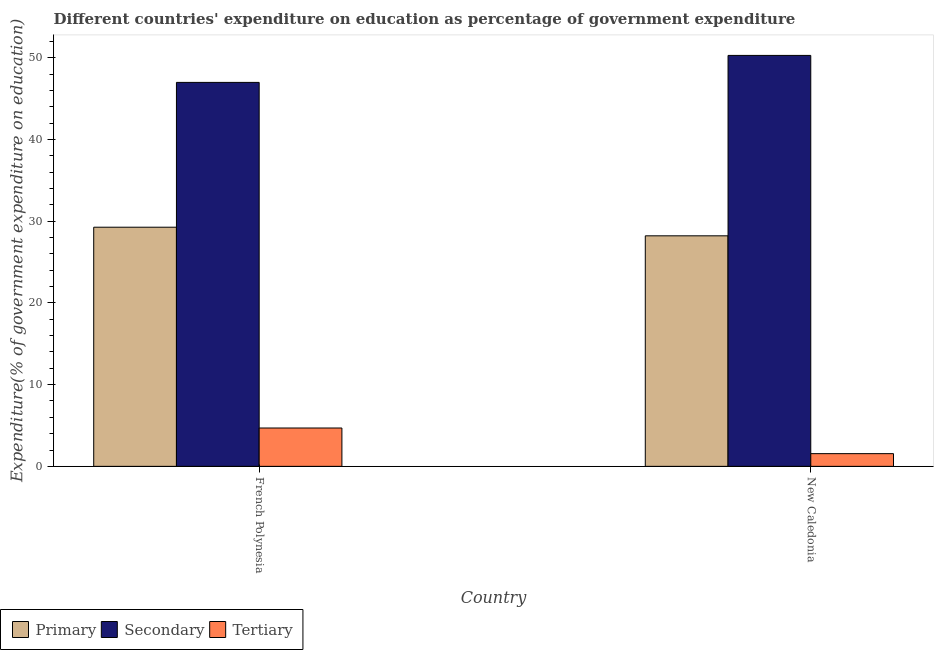How many different coloured bars are there?
Your response must be concise. 3. How many groups of bars are there?
Provide a short and direct response. 2. Are the number of bars on each tick of the X-axis equal?
Ensure brevity in your answer.  Yes. What is the label of the 2nd group of bars from the left?
Offer a very short reply. New Caledonia. In how many cases, is the number of bars for a given country not equal to the number of legend labels?
Make the answer very short. 0. What is the expenditure on tertiary education in New Caledonia?
Make the answer very short. 1.55. Across all countries, what is the maximum expenditure on secondary education?
Make the answer very short. 50.29. Across all countries, what is the minimum expenditure on tertiary education?
Your response must be concise. 1.55. In which country was the expenditure on primary education maximum?
Your answer should be very brief. French Polynesia. In which country was the expenditure on secondary education minimum?
Keep it short and to the point. French Polynesia. What is the total expenditure on primary education in the graph?
Your answer should be compact. 57.47. What is the difference between the expenditure on secondary education in French Polynesia and that in New Caledonia?
Give a very brief answer. -3.3. What is the difference between the expenditure on primary education in French Polynesia and the expenditure on tertiary education in New Caledonia?
Your answer should be very brief. 27.71. What is the average expenditure on secondary education per country?
Offer a very short reply. 48.64. What is the difference between the expenditure on tertiary education and expenditure on secondary education in New Caledonia?
Offer a very short reply. -48.73. What is the ratio of the expenditure on secondary education in French Polynesia to that in New Caledonia?
Your answer should be compact. 0.93. Is the expenditure on secondary education in French Polynesia less than that in New Caledonia?
Ensure brevity in your answer.  Yes. In how many countries, is the expenditure on tertiary education greater than the average expenditure on tertiary education taken over all countries?
Your answer should be very brief. 1. What does the 2nd bar from the left in New Caledonia represents?
Your answer should be compact. Secondary. What does the 3rd bar from the right in French Polynesia represents?
Your answer should be very brief. Primary. Is it the case that in every country, the sum of the expenditure on primary education and expenditure on secondary education is greater than the expenditure on tertiary education?
Offer a terse response. Yes. Are all the bars in the graph horizontal?
Offer a very short reply. No. What is the difference between two consecutive major ticks on the Y-axis?
Make the answer very short. 10. Does the graph contain any zero values?
Give a very brief answer. No. Does the graph contain grids?
Offer a very short reply. No. What is the title of the graph?
Offer a terse response. Different countries' expenditure on education as percentage of government expenditure. Does "Social Protection" appear as one of the legend labels in the graph?
Provide a short and direct response. No. What is the label or title of the Y-axis?
Provide a succinct answer. Expenditure(% of government expenditure on education). What is the Expenditure(% of government expenditure on education) in Primary in French Polynesia?
Give a very brief answer. 29.26. What is the Expenditure(% of government expenditure on education) in Secondary in French Polynesia?
Offer a terse response. 46.98. What is the Expenditure(% of government expenditure on education) in Tertiary in French Polynesia?
Give a very brief answer. 4.69. What is the Expenditure(% of government expenditure on education) in Primary in New Caledonia?
Make the answer very short. 28.21. What is the Expenditure(% of government expenditure on education) in Secondary in New Caledonia?
Offer a terse response. 50.29. What is the Expenditure(% of government expenditure on education) in Tertiary in New Caledonia?
Your response must be concise. 1.55. Across all countries, what is the maximum Expenditure(% of government expenditure on education) of Primary?
Provide a short and direct response. 29.26. Across all countries, what is the maximum Expenditure(% of government expenditure on education) of Secondary?
Provide a short and direct response. 50.29. Across all countries, what is the maximum Expenditure(% of government expenditure on education) of Tertiary?
Offer a very short reply. 4.69. Across all countries, what is the minimum Expenditure(% of government expenditure on education) of Primary?
Your answer should be compact. 28.21. Across all countries, what is the minimum Expenditure(% of government expenditure on education) in Secondary?
Keep it short and to the point. 46.98. Across all countries, what is the minimum Expenditure(% of government expenditure on education) in Tertiary?
Give a very brief answer. 1.55. What is the total Expenditure(% of government expenditure on education) in Primary in the graph?
Provide a succinct answer. 57.47. What is the total Expenditure(% of government expenditure on education) of Secondary in the graph?
Ensure brevity in your answer.  97.27. What is the total Expenditure(% of government expenditure on education) of Tertiary in the graph?
Provide a succinct answer. 6.24. What is the difference between the Expenditure(% of government expenditure on education) of Primary in French Polynesia and that in New Caledonia?
Your answer should be very brief. 1.05. What is the difference between the Expenditure(% of government expenditure on education) in Secondary in French Polynesia and that in New Caledonia?
Make the answer very short. -3.3. What is the difference between the Expenditure(% of government expenditure on education) of Tertiary in French Polynesia and that in New Caledonia?
Keep it short and to the point. 3.14. What is the difference between the Expenditure(% of government expenditure on education) of Primary in French Polynesia and the Expenditure(% of government expenditure on education) of Secondary in New Caledonia?
Provide a succinct answer. -21.02. What is the difference between the Expenditure(% of government expenditure on education) of Primary in French Polynesia and the Expenditure(% of government expenditure on education) of Tertiary in New Caledonia?
Your answer should be very brief. 27.71. What is the difference between the Expenditure(% of government expenditure on education) in Secondary in French Polynesia and the Expenditure(% of government expenditure on education) in Tertiary in New Caledonia?
Your response must be concise. 45.43. What is the average Expenditure(% of government expenditure on education) in Primary per country?
Give a very brief answer. 28.74. What is the average Expenditure(% of government expenditure on education) of Secondary per country?
Your answer should be compact. 48.64. What is the average Expenditure(% of government expenditure on education) in Tertiary per country?
Give a very brief answer. 3.12. What is the difference between the Expenditure(% of government expenditure on education) of Primary and Expenditure(% of government expenditure on education) of Secondary in French Polynesia?
Offer a very short reply. -17.72. What is the difference between the Expenditure(% of government expenditure on education) of Primary and Expenditure(% of government expenditure on education) of Tertiary in French Polynesia?
Your answer should be compact. 24.57. What is the difference between the Expenditure(% of government expenditure on education) of Secondary and Expenditure(% of government expenditure on education) of Tertiary in French Polynesia?
Offer a terse response. 42.29. What is the difference between the Expenditure(% of government expenditure on education) in Primary and Expenditure(% of government expenditure on education) in Secondary in New Caledonia?
Ensure brevity in your answer.  -22.08. What is the difference between the Expenditure(% of government expenditure on education) of Primary and Expenditure(% of government expenditure on education) of Tertiary in New Caledonia?
Your answer should be very brief. 26.66. What is the difference between the Expenditure(% of government expenditure on education) in Secondary and Expenditure(% of government expenditure on education) in Tertiary in New Caledonia?
Provide a short and direct response. 48.73. What is the ratio of the Expenditure(% of government expenditure on education) of Primary in French Polynesia to that in New Caledonia?
Provide a succinct answer. 1.04. What is the ratio of the Expenditure(% of government expenditure on education) of Secondary in French Polynesia to that in New Caledonia?
Provide a succinct answer. 0.93. What is the ratio of the Expenditure(% of government expenditure on education) of Tertiary in French Polynesia to that in New Caledonia?
Offer a terse response. 3.02. What is the difference between the highest and the second highest Expenditure(% of government expenditure on education) of Primary?
Offer a very short reply. 1.05. What is the difference between the highest and the second highest Expenditure(% of government expenditure on education) in Secondary?
Offer a very short reply. 3.3. What is the difference between the highest and the second highest Expenditure(% of government expenditure on education) of Tertiary?
Ensure brevity in your answer.  3.14. What is the difference between the highest and the lowest Expenditure(% of government expenditure on education) in Primary?
Your answer should be very brief. 1.05. What is the difference between the highest and the lowest Expenditure(% of government expenditure on education) of Secondary?
Ensure brevity in your answer.  3.3. What is the difference between the highest and the lowest Expenditure(% of government expenditure on education) of Tertiary?
Offer a very short reply. 3.14. 